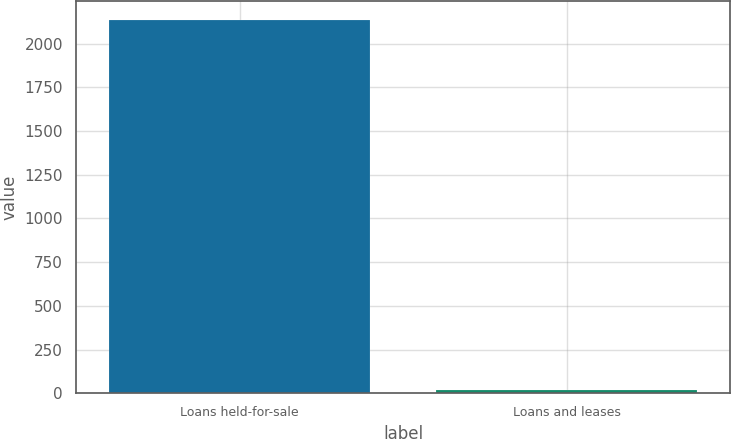Convert chart. <chart><loc_0><loc_0><loc_500><loc_500><bar_chart><fcel>Loans held-for-sale<fcel>Loans and leases<nl><fcel>2138<fcel>18<nl></chart> 